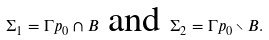Convert formula to latex. <formula><loc_0><loc_0><loc_500><loc_500>\Sigma _ { 1 } = \Gamma p _ { 0 } \cap B \text { and } \Sigma _ { 2 } = \Gamma p _ { 0 } \smallsetminus B .</formula> 